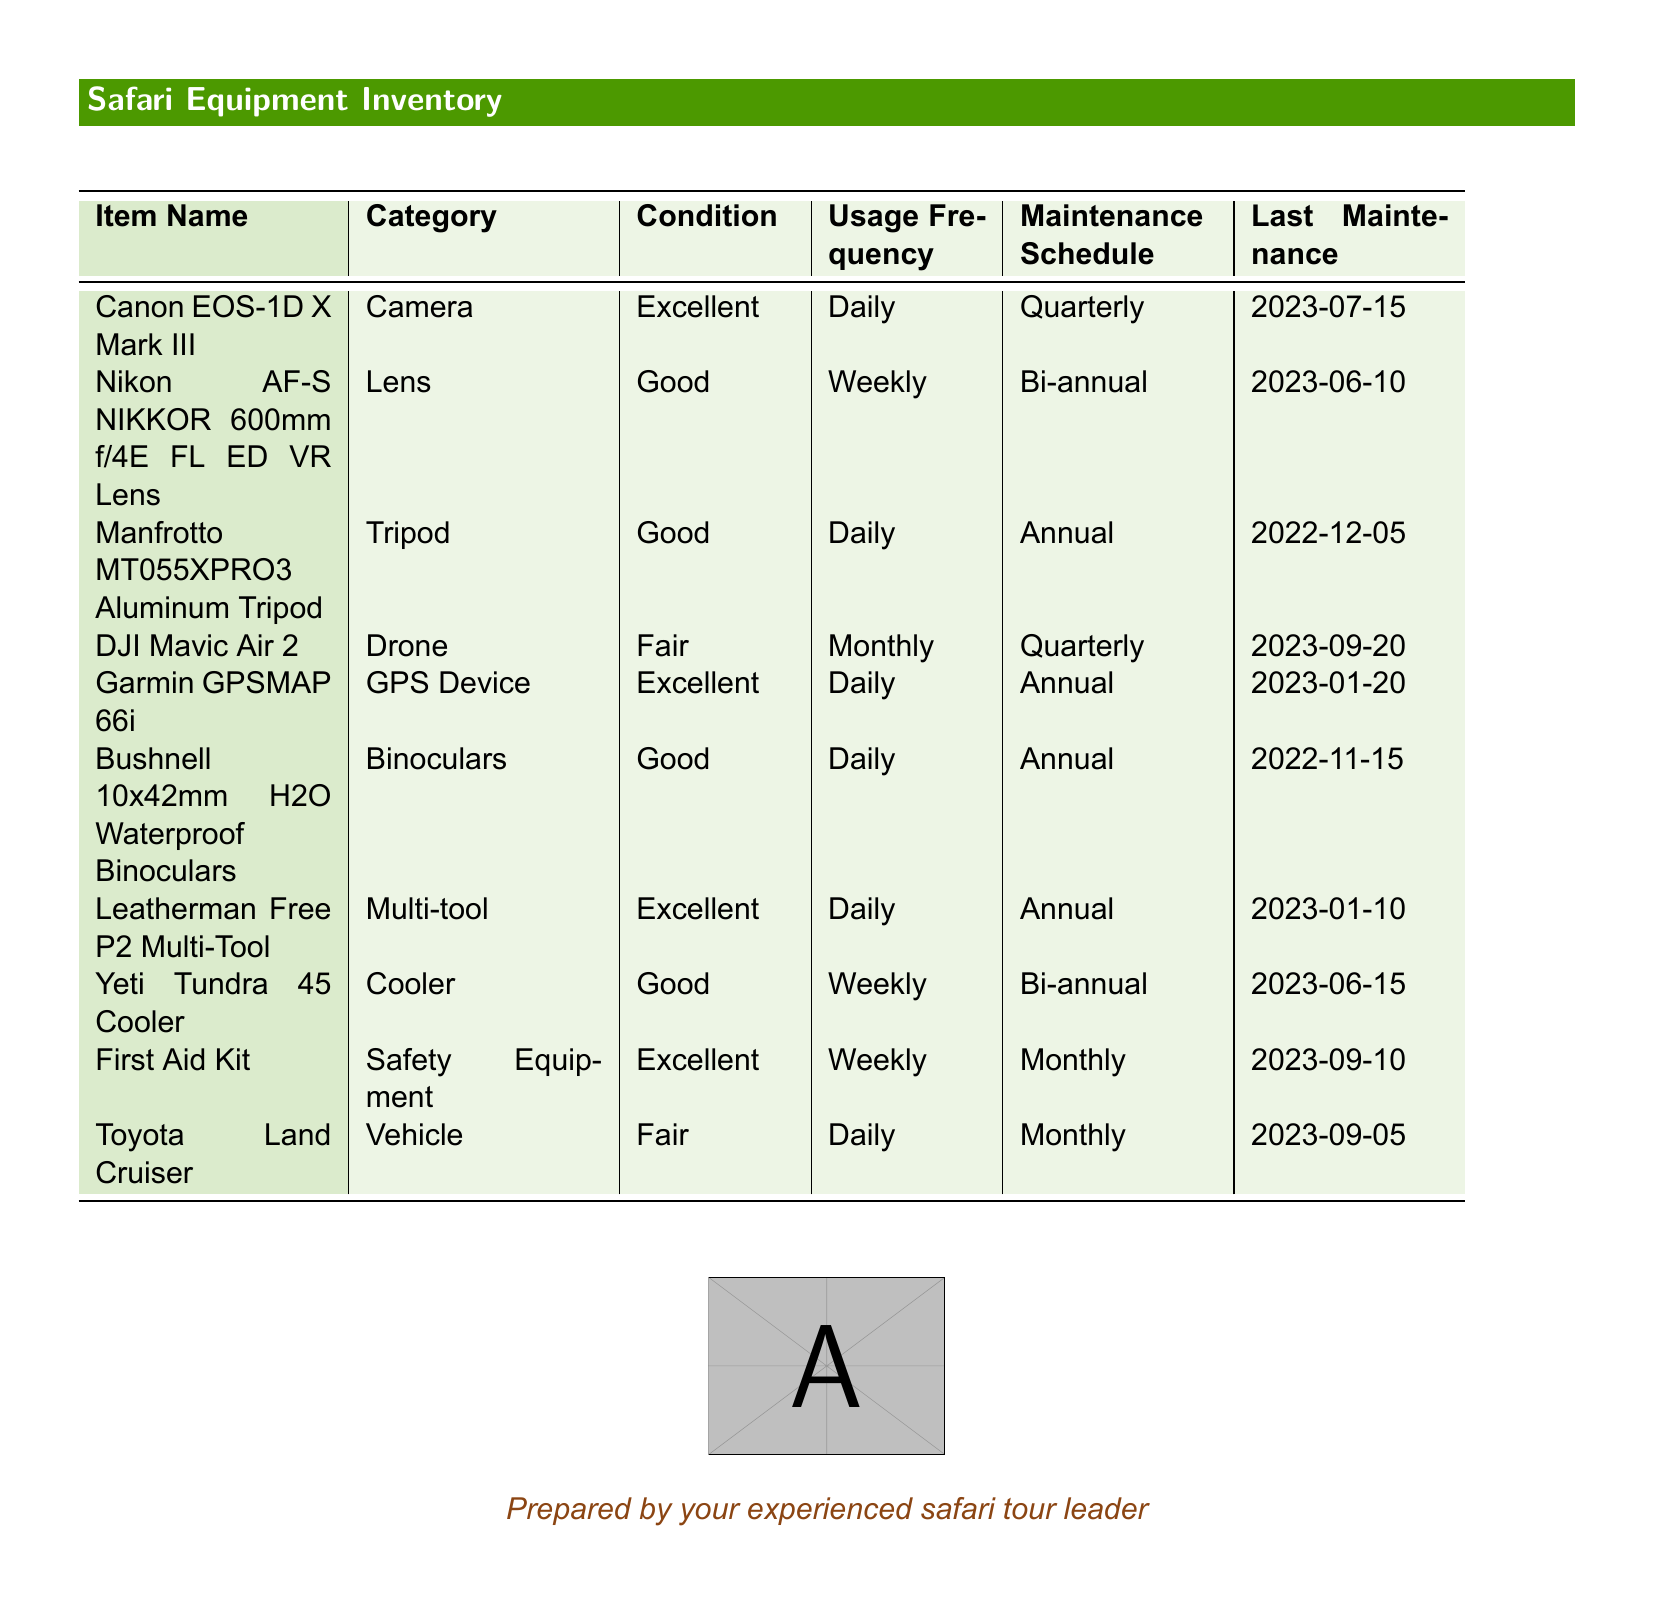What is the condition of the Canon EOS-1D X Mark III? The condition is provided in the document under the "Condition" column for the relevant item.
Answer: Excellent How frequently is the Manfrotto MT055XPRO3 Aluminum Tripod used? The document states the usage frequency of the tripod in the relevant section.
Answer: Daily When was the last maintenance performed on the Toyota Land Cruiser? The document specifies the date of last maintenance in the "Last Maintenance" column.
Answer: 2023-09-05 Which item has a maintenance schedule of monthly? This question requires you to check the "Maintenance Schedule" column to find the relevant item.
Answer: Toyota Land Cruiser What is the category of the DJI Mavic Air 2? The category is listed in the document under the "Category" column for the relevant item.
Answer: Drone Which equipment has the best condition? This question requires comparison of conditions listed in the document.
Answer: Canon EOS-1D X Mark III and Garmin GPSMAP 66i How often is the First Aid Kit maintained? The frequency of maintenance is specified in the "Maintenance Schedule" section of the document.
Answer: Monthly What is the usage frequency of the Yeti Tundra 45 Cooler? The document indicates how often the cooler is used in the provided section.
Answer: Weekly 